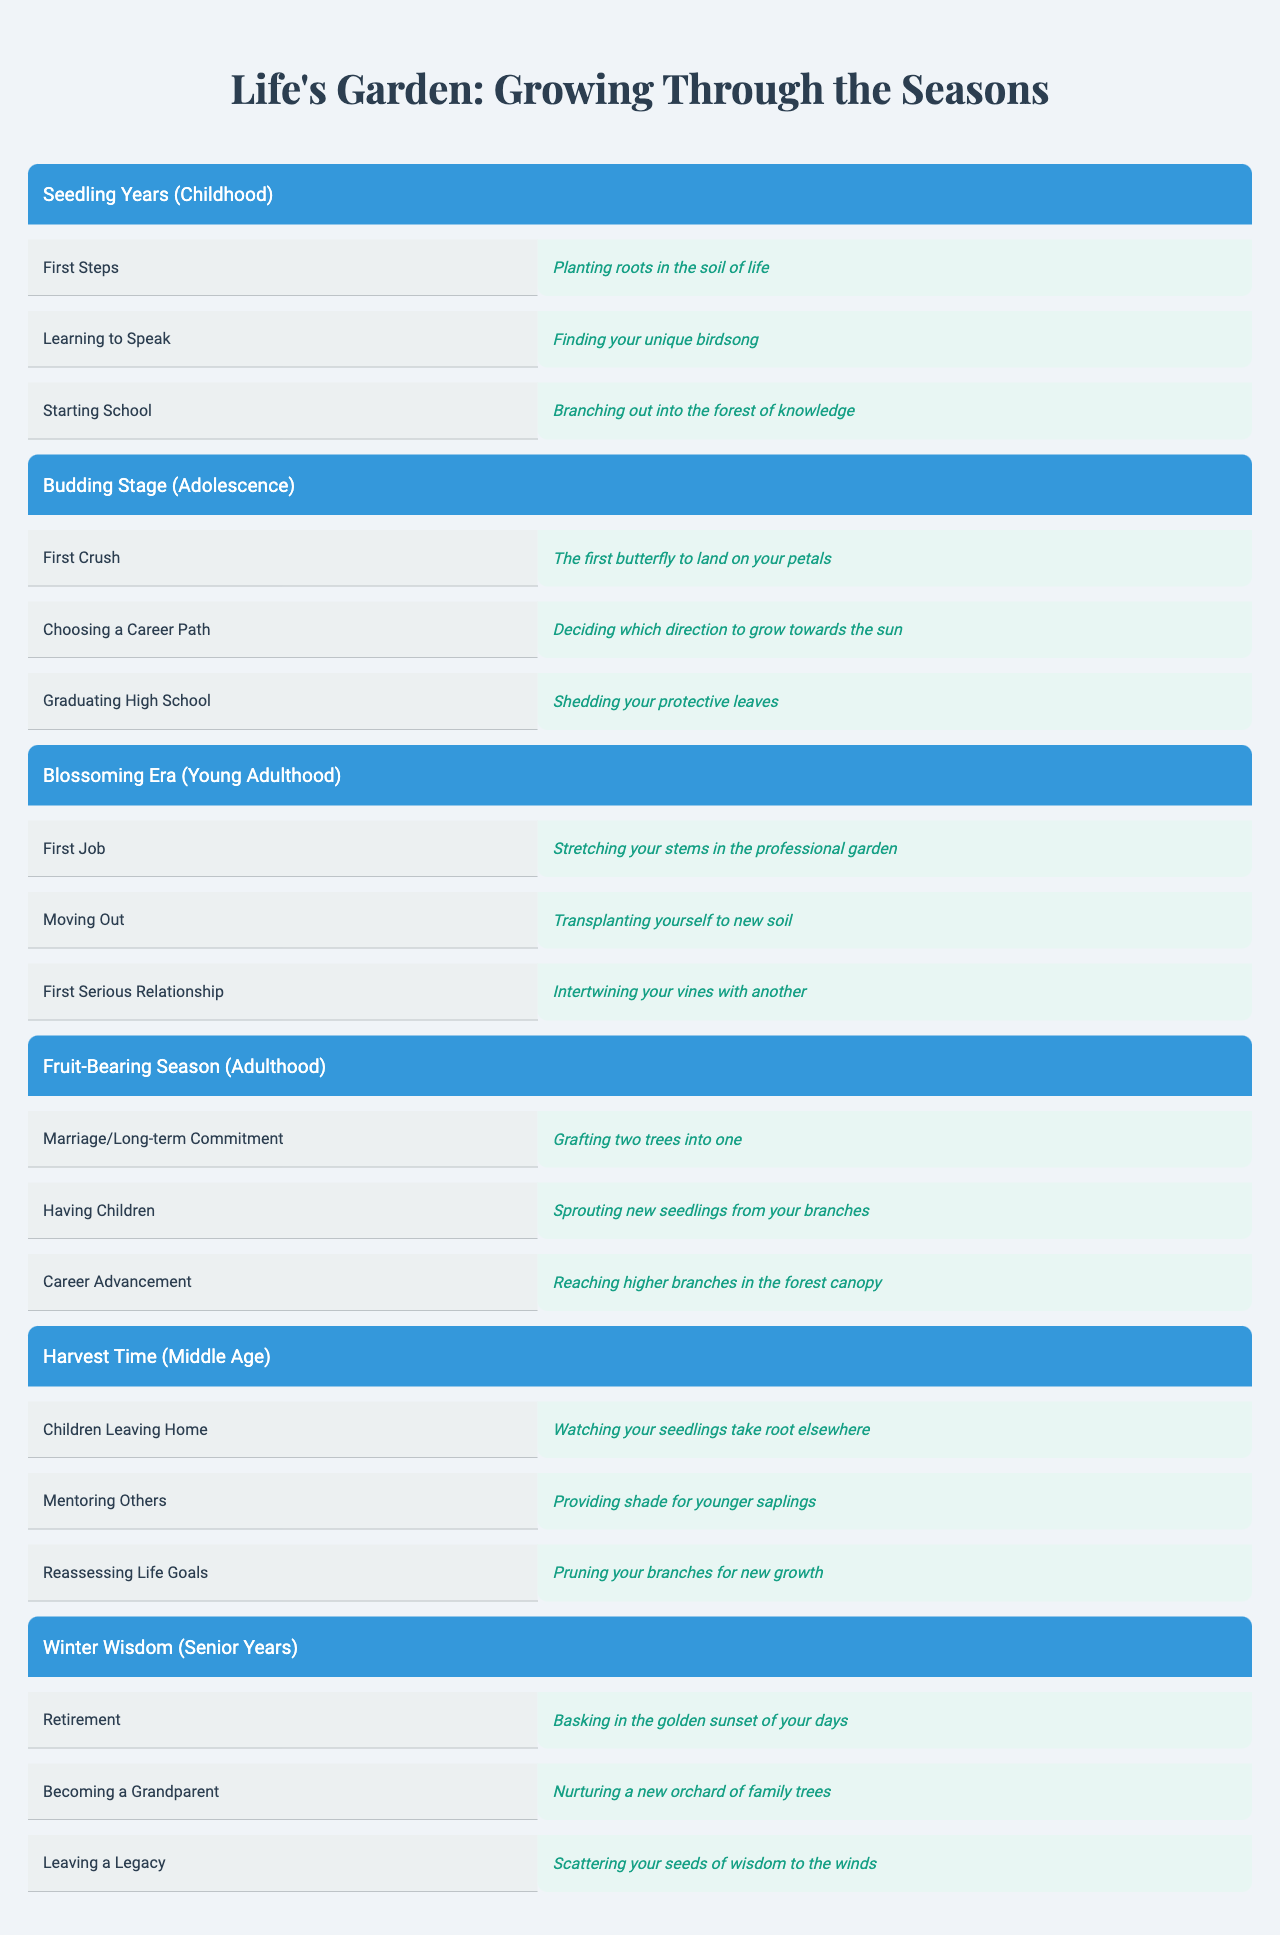What are the growth milestones during the Seedling Years? In the Seedling Years phase, the table lists three growth milestones: First Steps, Learning to Speak, and Starting School.
Answer: First Steps, Learning to Speak, Starting School Which milestone is associated with the metaphor about butterflies in the Budding Stage? In the Budding Stage, the milestone related to butterflies is "First Crush," which is described as "The first butterfly to land on your petals."
Answer: First Crush How many milestones are there in the Blossoming Era? The Blossoming Era has three milestones listed: First Job, Moving Out, and First Serious Relationship, resulting in a total of three milestones.
Answer: 3 Is "Children Leaving Home" one of the milestones listed in the Harvest Time phase? Yes, "Children Leaving Home" is clearly listed as a milestone in the Harvest Time phase.
Answer: Yes What is the metaphor for "Having Children" in the Fruit-Bearing Season? The metaphor for "Having Children" is "Sprouting new seedlings from your branches."
Answer: Sprouting new seedlings from your branches Which phase contains the milestone of "Mentoring Others"? The "Mentoring Others" milestone is found in the Harvest Time phase, which focuses on guiding and supporting others.
Answer: Harvest Time If you consider all the growth milestones listed, how many involve a direct reference to nature? Each milestone directly ties to nature in various ways, and there are a total of 15 milestones listed across all phases, all containing nature-related language.
Answer: 15 In which phase would you find the metaphor, "Basking in the golden sunset of your days"? This metaphor belongs to the Winter Wisdom phase and describes the milestone of retirement as a time of reflection.
Answer: Winter Wisdom What is the metaphor associated with the first job in the Blossoming Era? The metaphor for the first job in the Blossoming Era is "Stretching your stems in the professional garden."
Answer: Stretching your stems in the professional garden How does the metaphor “Reaching higher branches in the forest canopy” relate to personal growth? This metaphor describes the milestone of "Career Advancement" in the Fruit-Bearing Season, symbolizing striving for higher achievements in one’s career.
Answer: Career Advancement 